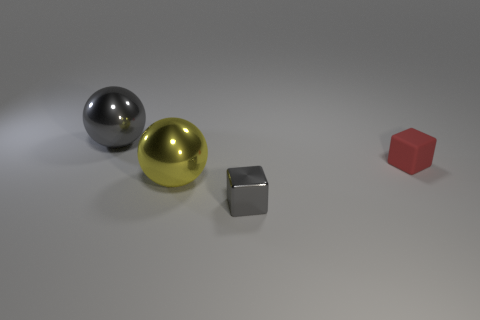There is a yellow object behind the gray thing in front of the large gray shiny thing; what is its size?
Offer a terse response. Large. What number of red blocks are the same size as the gray metal cube?
Provide a succinct answer. 1. There is a object that is in front of the yellow shiny ball; is it the same color as the large ball behind the tiny rubber cube?
Offer a very short reply. Yes. Are there any gray shiny blocks to the right of the large yellow metallic sphere?
Provide a succinct answer. Yes. The object that is both behind the yellow sphere and in front of the large gray sphere is what color?
Make the answer very short. Red. Are there any objects of the same color as the small shiny block?
Offer a very short reply. Yes. Are the gray object right of the yellow object and the gray thing left of the tiny shiny object made of the same material?
Ensure brevity in your answer.  Yes. What is the size of the thing that is on the left side of the yellow metal thing?
Give a very brief answer. Large. What size is the red rubber cube?
Offer a terse response. Small. What size is the gray metallic thing that is in front of the gray object that is on the left side of the block that is in front of the matte object?
Give a very brief answer. Small. 